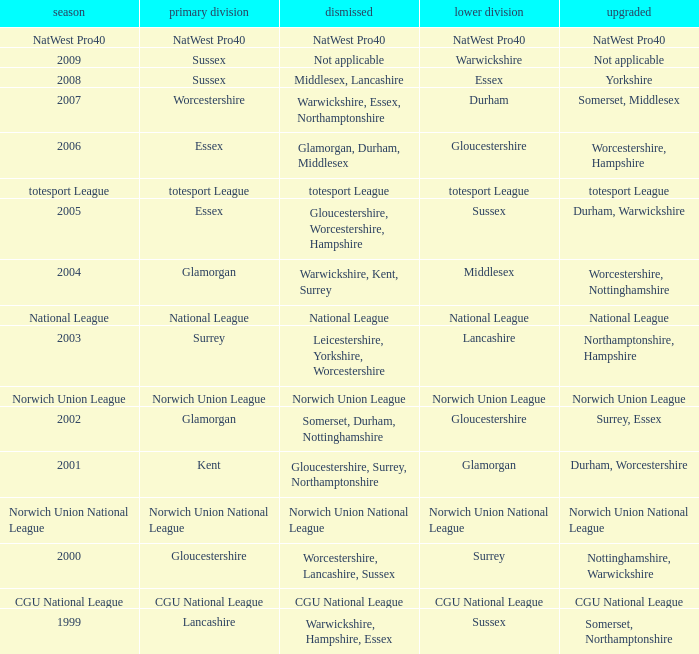What is the 1st division when the 2nd division is national league? National League. 